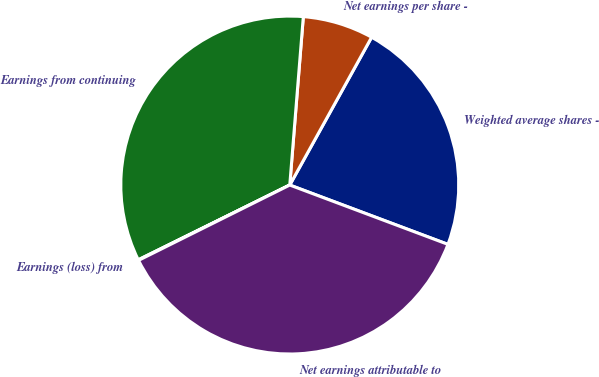Convert chart. <chart><loc_0><loc_0><loc_500><loc_500><pie_chart><fcel>Weighted average shares -<fcel>Net earnings per share -<fcel>Earnings from continuing<fcel>Earnings (loss) from<fcel>Net earnings attributable to<nl><fcel>22.66%<fcel>6.77%<fcel>33.57%<fcel>0.06%<fcel>36.93%<nl></chart> 